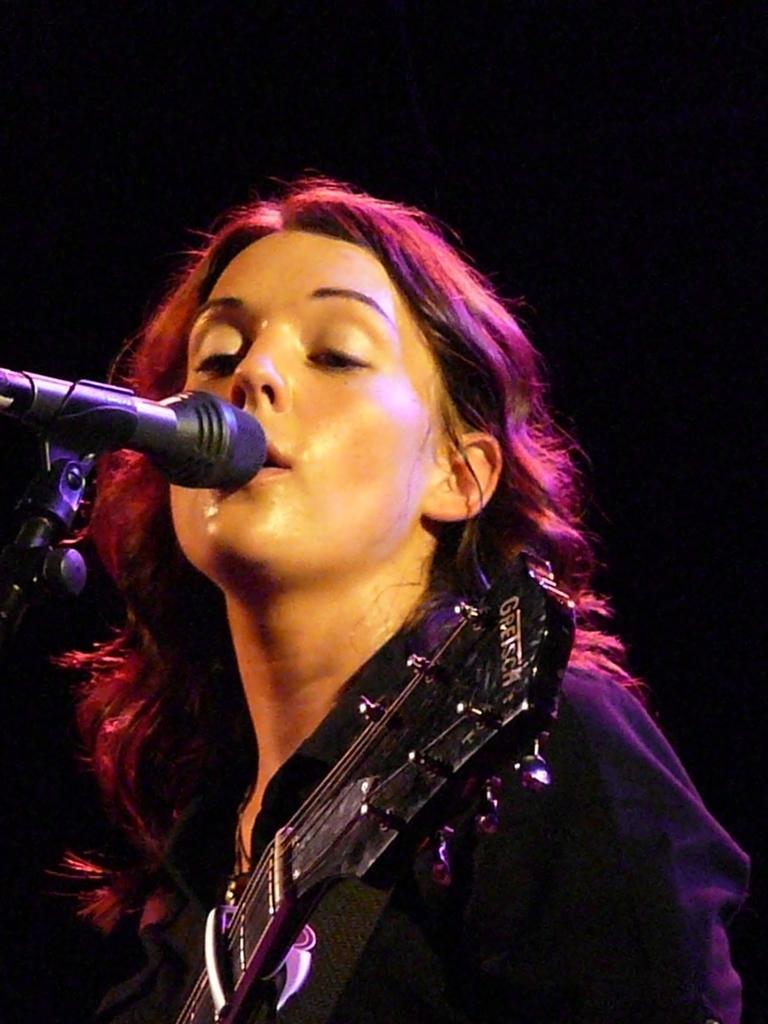Could you give a brief overview of what you see in this image? A woman wearing black dress is singing. In front of her there is a mic and she is holding a guitar. 